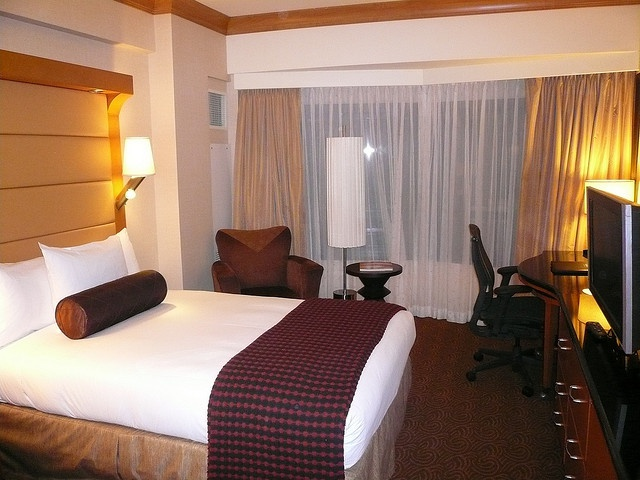Describe the objects in this image and their specific colors. I can see bed in gray, lightgray, maroon, and black tones, tv in gray, black, maroon, and ivory tones, chair in gray, maroon, black, and darkgray tones, chair in gray and black tones, and book in gray, brown, and darkgray tones in this image. 